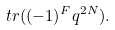Convert formula to latex. <formula><loc_0><loc_0><loc_500><loc_500>t r ( ( - 1 ) ^ { F } q ^ { 2 N } ) .</formula> 